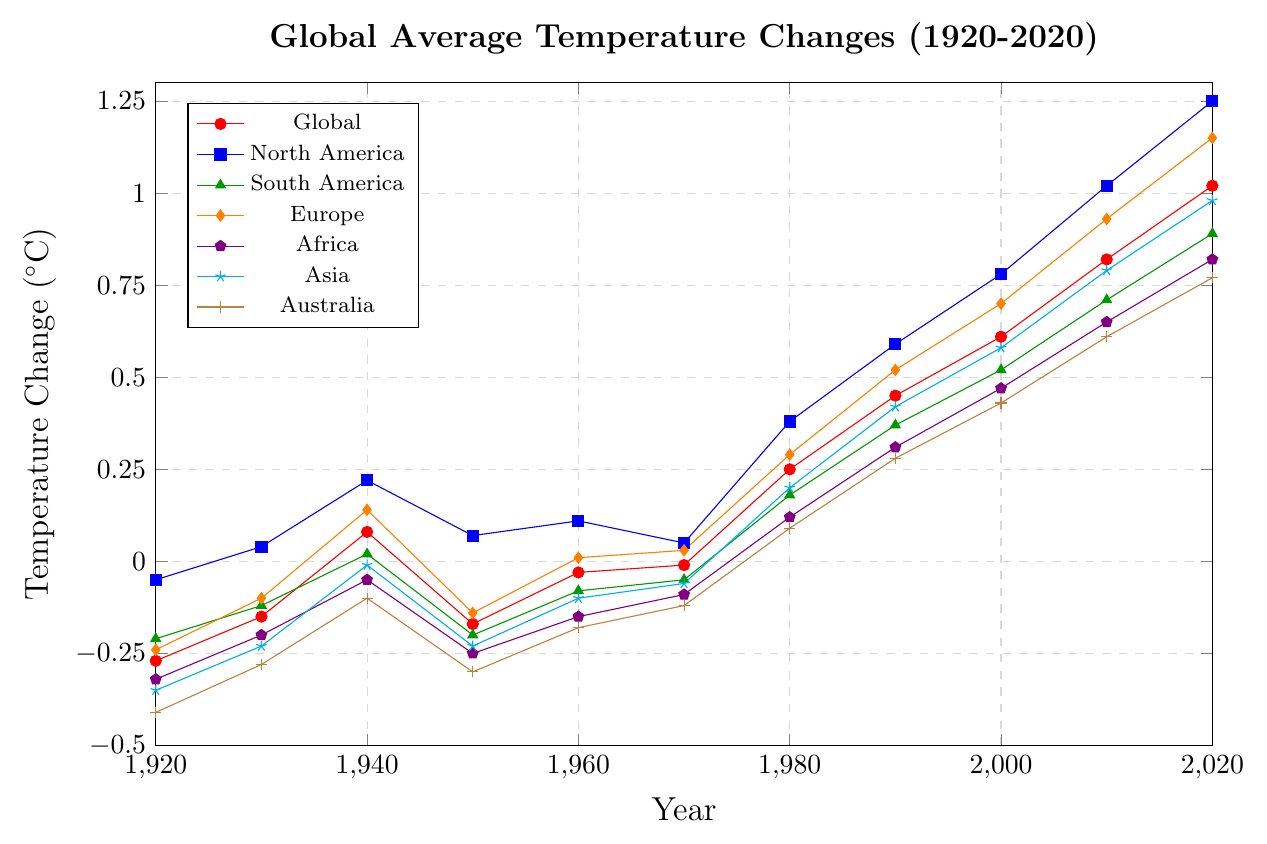What was the global average temperature change in 2020? Locate the Global line and check the value at the year 2020 on the x-axis. The value is 1.02.
Answer: 1.02 Which continent had the highest temperature change in 2020? Compare the values of all continents at the year 2020: North America (1.25), South America (0.89), Europe (1.15), Africa (0.82), Asia (0.98), and Australia (0.77). North America has the highest value.
Answer: North America How much did the temperature change in Europe between 1920 and 2020? Subtract the temperature change in 1920 from that in 2020 for Europe. The values are -0.24 (1920) and 1.15 (2020). The difference is 1.15 - (-0.24) = 1.39.
Answer: 1.39 Which two continents have shown the similar temperature change trends over the century? Visually examine the trends of the lines for each continent. Africa and South America have similar trends, staying relatively low until around 1980 and then increasing steadily.
Answer: Africa and South America By how much did the temperature change in Asia from 1980 to 2000? Subtract the temperature change in 1980 from that in 2000 for Asia. The values are 0.20 (1980) and 0.58 (2000). The difference is 0.58 - 0.20 = 0.38.
Answer: 0.38 Which continent had the lowest temperature change in 1930? Compare the temperature changes in 1930 for all continents: North America (0.04), South America (-0.12), Europe (-0.10), Africa (-0.20), Asia (-0.23), Australia (-0.28). Australasia has the lowest value.
Answer: Australasia What was the average global temperature change in the 1960s? Locate data points for Global in 1960 and 1970. The values are -0.03 (1960) and -0.01 (1970). The average is (-0.03 + -0.01) / 2 = -0.02.
Answer: -0.02 Which two continents had the most similar temperature change in 1950? Compare the temperature changes in 1950 for each continent: North America (0.07), South America (-0.20), Europe (-0.14), Africa (-0.25), Asia (-0.23), and Australia (-0.30). Asia and Africa have the closest values.
Answer: Asia and Africa Was there any continent where the temperature change in 2000 was lower than 1990? If yes, which one? Compare the temperature changes in 1990 and 2000 for all continents. All continents show an increase from 1990 to 2000.
Answer: No Which continent experienced the highest increase in temperature change between 1980 and 2020? Calculate the increase for each continent between 1980 and 2020, then compare: North America (1.25-0.38 = 0.87), South America (0.89-0.18 = 0.71), Europe (1.15-0.29 = 0.86), Africa (0.82-0.12 = 0.70), Asia (0.98-0.20 = 0.78), Australia (0.77-0.09 = 0.68). North America has the highest increase.
Answer: North America 